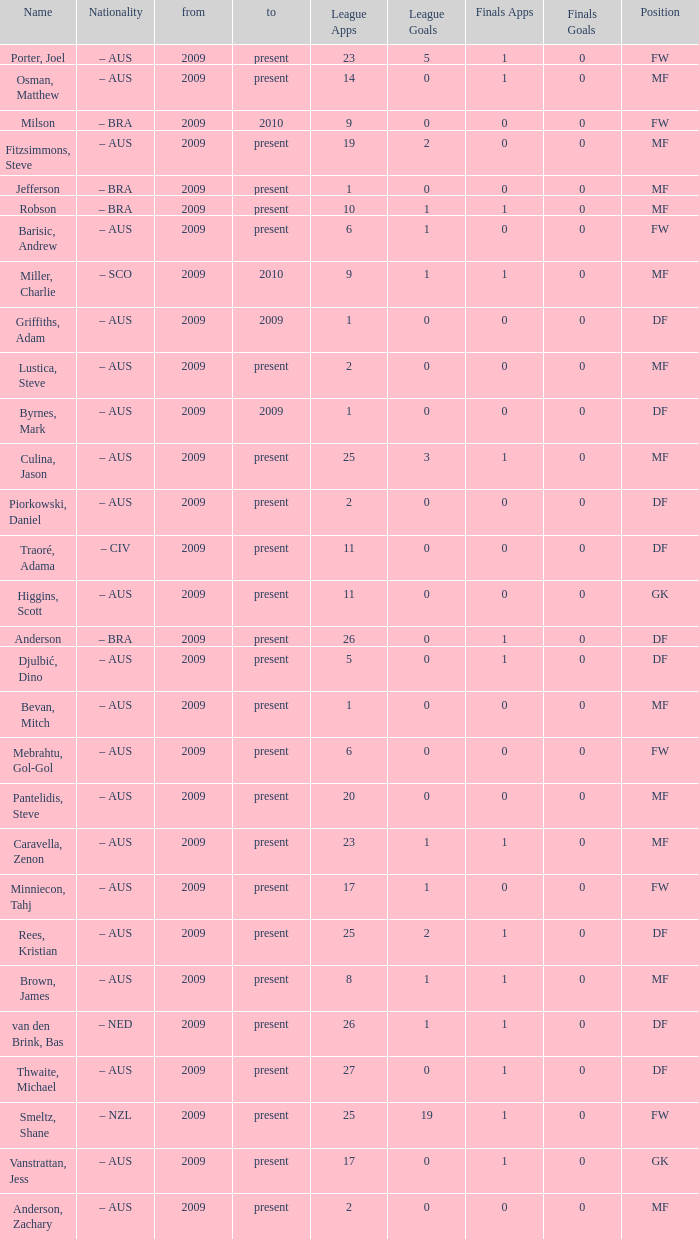Name the position for van den brink, bas DF. 